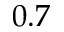<formula> <loc_0><loc_0><loc_500><loc_500>0 . 7</formula> 